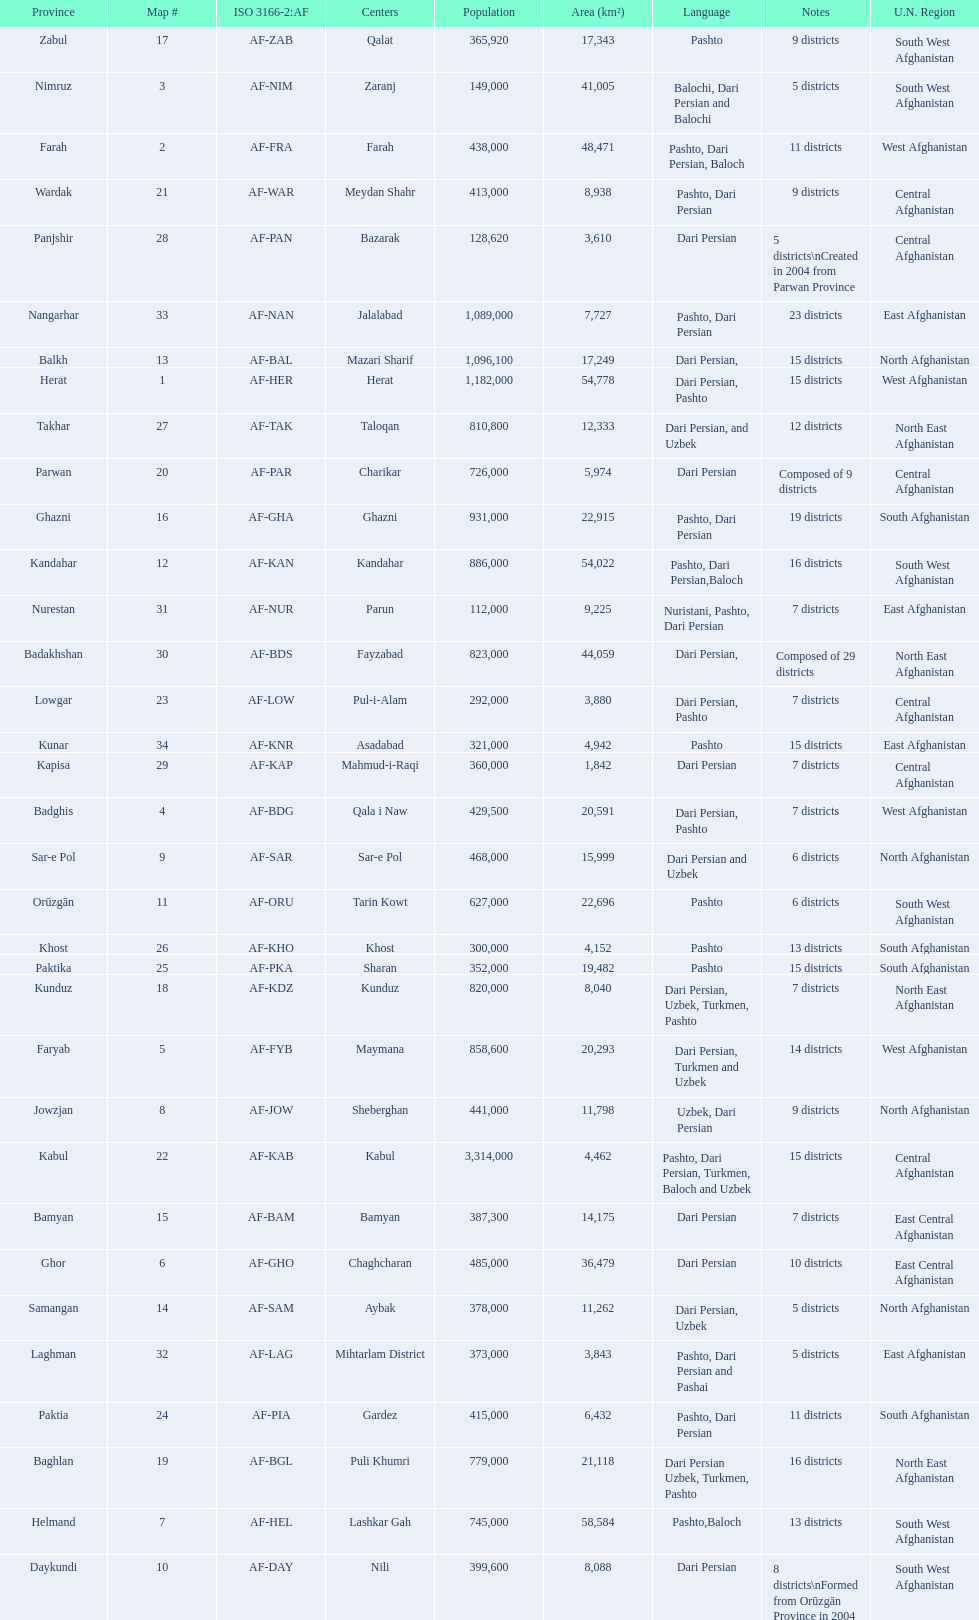Could you parse the entire table? {'header': ['Province', 'Map #', 'ISO 3166-2:AF', 'Centers', 'Population', 'Area (km²)', 'Language', 'Notes', 'U.N. Region'], 'rows': [['Zabul', '17', 'AF-ZAB', 'Qalat', '365,920', '17,343', 'Pashto', '9 districts', 'South West Afghanistan'], ['Nimruz', '3', 'AF-NIM', 'Zaranj', '149,000', '41,005', 'Balochi, Dari Persian and Balochi', '5 districts', 'South West Afghanistan'], ['Farah', '2', 'AF-FRA', 'Farah', '438,000', '48,471', 'Pashto, Dari Persian, Baloch', '11 districts', 'West Afghanistan'], ['Wardak', '21', 'AF-WAR', 'Meydan Shahr', '413,000', '8,938', 'Pashto, Dari Persian', '9 districts', 'Central Afghanistan'], ['Panjshir', '28', 'AF-PAN', 'Bazarak', '128,620', '3,610', 'Dari Persian', '5 districts\\nCreated in 2004 from Parwan Province', 'Central Afghanistan'], ['Nangarhar', '33', 'AF-NAN', 'Jalalabad', '1,089,000', '7,727', 'Pashto, Dari Persian', '23 districts', 'East Afghanistan'], ['Balkh', '13', 'AF-BAL', 'Mazari Sharif', '1,096,100', '17,249', 'Dari Persian,', '15 districts', 'North Afghanistan'], ['Herat', '1', 'AF-HER', 'Herat', '1,182,000', '54,778', 'Dari Persian, Pashto', '15 districts', 'West Afghanistan'], ['Takhar', '27', 'AF-TAK', 'Taloqan', '810,800', '12,333', 'Dari Persian, and Uzbek', '12 districts', 'North East Afghanistan'], ['Parwan', '20', 'AF-PAR', 'Charikar', '726,000', '5,974', 'Dari Persian', 'Composed of 9 districts', 'Central Afghanistan'], ['Ghazni', '16', 'AF-GHA', 'Ghazni', '931,000', '22,915', 'Pashto, Dari Persian', '19 districts', 'South Afghanistan'], ['Kandahar', '12', 'AF-KAN', 'Kandahar', '886,000', '54,022', 'Pashto, Dari Persian,Baloch', '16 districts', 'South West Afghanistan'], ['Nurestan', '31', 'AF-NUR', 'Parun', '112,000', '9,225', 'Nuristani, Pashto, Dari Persian', '7 districts', 'East Afghanistan'], ['Badakhshan', '30', 'AF-BDS', 'Fayzabad', '823,000', '44,059', 'Dari Persian,', 'Composed of 29 districts', 'North East Afghanistan'], ['Lowgar', '23', 'AF-LOW', 'Pul-i-Alam', '292,000', '3,880', 'Dari Persian, Pashto', '7 districts', 'Central Afghanistan'], ['Kunar', '34', 'AF-KNR', 'Asadabad', '321,000', '4,942', 'Pashto', '15 districts', 'East Afghanistan'], ['Kapisa', '29', 'AF-KAP', 'Mahmud-i-Raqi', '360,000', '1,842', 'Dari Persian', '7 districts', 'Central Afghanistan'], ['Badghis', '4', 'AF-BDG', 'Qala i Naw', '429,500', '20,591', 'Dari Persian, Pashto', '7 districts', 'West Afghanistan'], ['Sar-e Pol', '9', 'AF-SAR', 'Sar-e Pol', '468,000', '15,999', 'Dari Persian and Uzbek', '6 districts', 'North Afghanistan'], ['Orūzgān', '11', 'AF-ORU', 'Tarin Kowt', '627,000', '22,696', 'Pashto', '6 districts', 'South West Afghanistan'], ['Khost', '26', 'AF-KHO', 'Khost', '300,000', '4,152', 'Pashto', '13 districts', 'South Afghanistan'], ['Paktika', '25', 'AF-PKA', 'Sharan', '352,000', '19,482', 'Pashto', '15 districts', 'South Afghanistan'], ['Kunduz', '18', 'AF-KDZ', 'Kunduz', '820,000', '8,040', 'Dari Persian, Uzbek, Turkmen, Pashto', '7 districts', 'North East Afghanistan'], ['Faryab', '5', 'AF-FYB', 'Maymana', '858,600', '20,293', 'Dari Persian, Turkmen and Uzbek', '14 districts', 'West Afghanistan'], ['Jowzjan', '8', 'AF-JOW', 'Sheberghan', '441,000', '11,798', 'Uzbek, Dari Persian', '9 districts', 'North Afghanistan'], ['Kabul', '22', 'AF-KAB', 'Kabul', '3,314,000', '4,462', 'Pashto, Dari Persian, Turkmen, Baloch and Uzbek', '15 districts', 'Central Afghanistan'], ['Bamyan', '15', 'AF-BAM', 'Bamyan', '387,300', '14,175', 'Dari Persian', '7 districts', 'East Central Afghanistan'], ['Ghor', '6', 'AF-GHO', 'Chaghcharan', '485,000', '36,479', 'Dari Persian', '10 districts', 'East Central Afghanistan'], ['Samangan', '14', 'AF-SAM', 'Aybak', '378,000', '11,262', 'Dari Persian, Uzbek', '5 districts', 'North Afghanistan'], ['Laghman', '32', 'AF-LAG', 'Mihtarlam District', '373,000', '3,843', 'Pashto, Dari Persian and Pashai', '5 districts', 'East Afghanistan'], ['Paktia', '24', 'AF-PIA', 'Gardez', '415,000', '6,432', 'Pashto, Dari Persian', '11 districts', 'South Afghanistan'], ['Baghlan', '19', 'AF-BGL', 'Puli Khumri', '779,000', '21,118', 'Dari Persian Uzbek, Turkmen, Pashto', '16 districts', 'North East Afghanistan'], ['Helmand', '7', 'AF-HEL', 'Lashkar Gah', '745,000', '58,584', 'Pashto,Baloch', '13 districts', 'South West Afghanistan'], ['Daykundi', '10', 'AF-DAY', 'Nili', '399,600', '8,088', 'Dari Persian', '8 districts\\nFormed from Orūzgān Province in 2004', 'South West Afghanistan']]} What province is listed previous to ghor? Ghazni. 